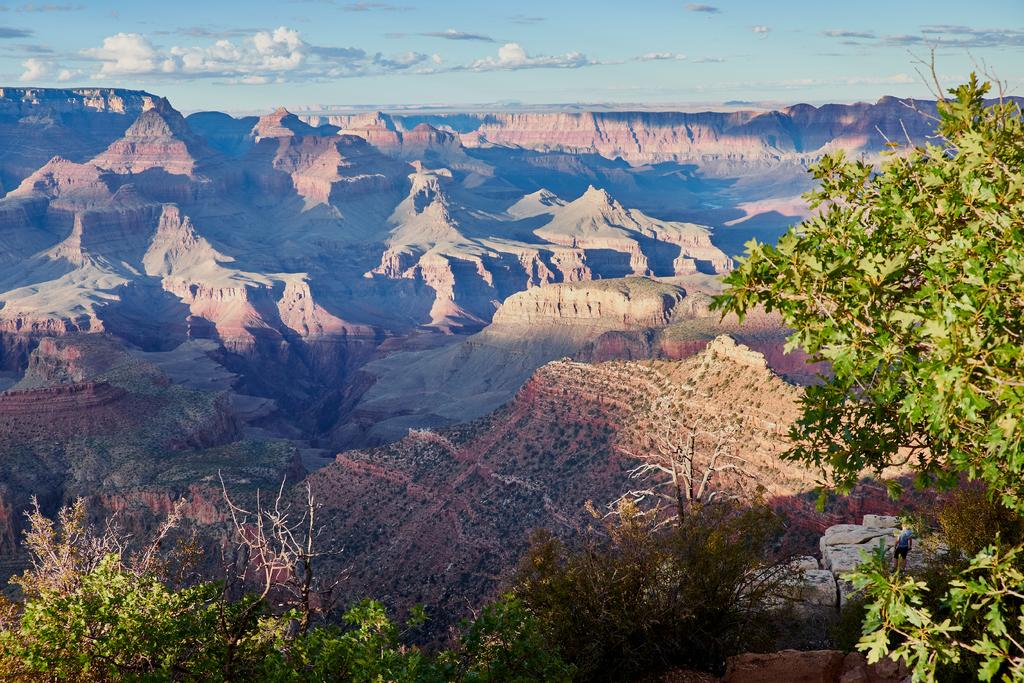What type of vegetation is in the foreground of the image? There are trees in the foreground of the image. What type of natural feature is in the background of the image? There are mountains in the background of the image. What part of the natural environment is visible in the background of the image? The sky is visible in the background of the image. Can you describe the sky in the image? There is a cloud in the sky. What type of sign can be seen in the image? There is no sign present in the image. Is there a gun visible in the image? There is no gun present in the image. 